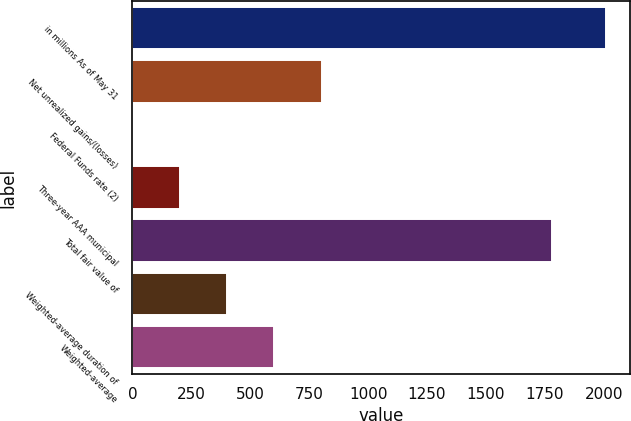Convert chart. <chart><loc_0><loc_0><loc_500><loc_500><bar_chart><fcel>in millions As of May 31<fcel>Net unrealized gains/(losses)<fcel>Federal Funds rate (2)<fcel>Three-year AAA municipal<fcel>Total fair value of<fcel>Weighted-average duration of<fcel>Weighted-average<nl><fcel>2009<fcel>803.75<fcel>0.25<fcel>201.12<fcel>1780.9<fcel>402<fcel>602.88<nl></chart> 